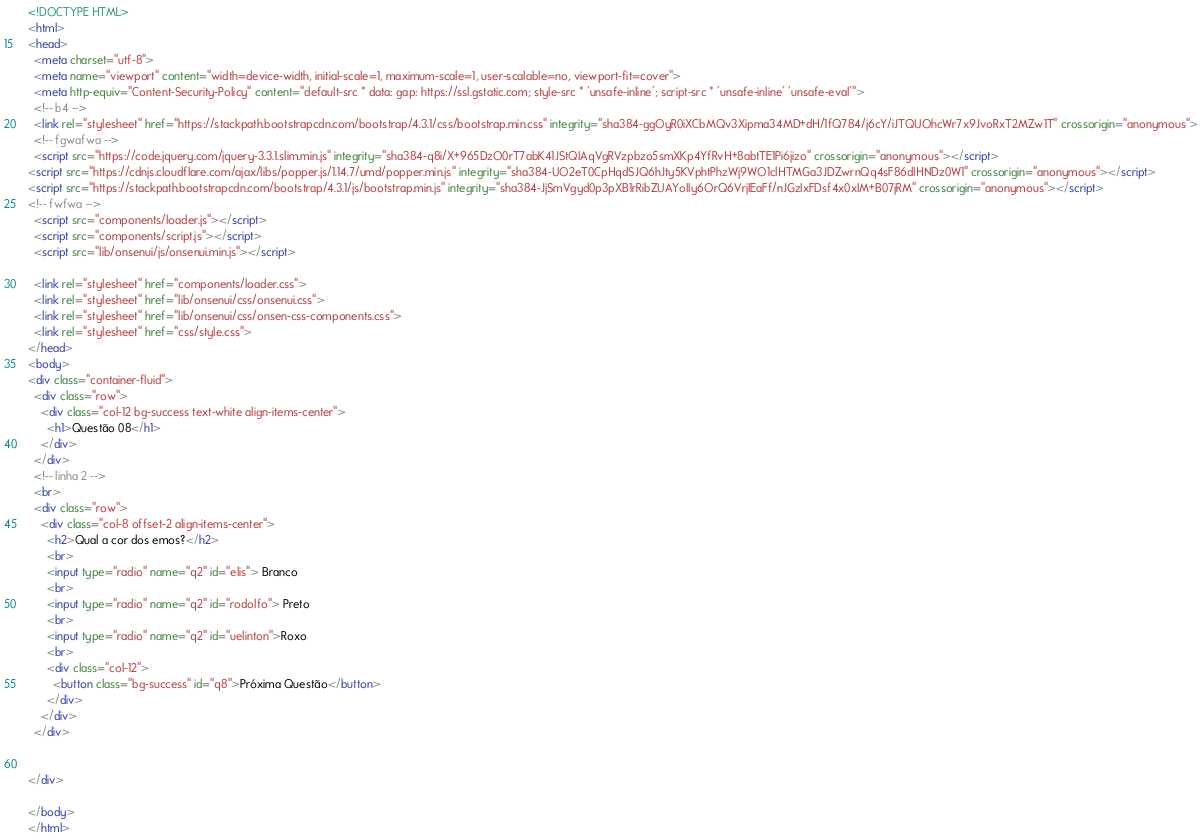Convert code to text. <code><loc_0><loc_0><loc_500><loc_500><_HTML_><!DOCTYPE HTML>
<html>
<head>
  <meta charset="utf-8">
  <meta name="viewport" content="width=device-width, initial-scale=1, maximum-scale=1, user-scalable=no, viewport-fit=cover">
  <meta http-equiv="Content-Security-Policy" content="default-src * data: gap: https://ssl.gstatic.com; style-src * 'unsafe-inline'; script-src * 'unsafe-inline' 'unsafe-eval'">
  <!-- b4 -->
  <link rel="stylesheet" href="https://stackpath.bootstrapcdn.com/bootstrap/4.3.1/css/bootstrap.min.css" integrity="sha384-ggOyR0iXCbMQv3Xipma34MD+dH/1fQ784/j6cY/iJTQUOhcWr7x9JvoRxT2MZw1T" crossorigin="anonymous">
  <!-- fgwafwa -->
  <script src="https://code.jquery.com/jquery-3.3.1.slim.min.js" integrity="sha384-q8i/X+965DzO0rT7abK41JStQIAqVgRVzpbzo5smXKp4YfRvH+8abtTE1Pi6jizo" crossorigin="anonymous"></script>
<script src="https://cdnjs.cloudflare.com/ajax/libs/popper.js/1.14.7/umd/popper.min.js" integrity="sha384-UO2eT0CpHqdSJQ6hJty5KVphtPhzWj9WO1clHTMGa3JDZwrnQq4sF86dIHNDz0W1" crossorigin="anonymous"></script>
<script src="https://stackpath.bootstrapcdn.com/bootstrap/4.3.1/js/bootstrap.min.js" integrity="sha384-JjSmVgyd0p3pXB1rRibZUAYoIIy6OrQ6VrjIEaFf/nJGzIxFDsf4x0xIM+B07jRM" crossorigin="anonymous"></script>
<!-- fwfwa -->
  <script src="components/loader.js"></script>
  <script src="components/script.js"></script>
  <script src="lib/onsenui/js/onsenui.min.js"></script>

  <link rel="stylesheet" href="components/loader.css">
  <link rel="stylesheet" href="lib/onsenui/css/onsenui.css">
  <link rel="stylesheet" href="lib/onsenui/css/onsen-css-components.css">
  <link rel="stylesheet" href="css/style.css">
</head>
<body>
<div class="container-fluid">
  <div class="row">
    <div class="col-12 bg-success text-white align-items-center">
      <h1>Questão 08</h1>
    </div>
  </div>
  <!-- linha 2 -->
  <br>
  <div class="row">
    <div class="col-8 offset-2 align-items-center">
      <h2>Qual a cor dos emos?</h2>
      <br>
      <input type="radio" name="q2" id="elis"> Branco
      <br>
      <input type="radio" name="q2" id="rodolfo"> Preto
      <br>
      <input type="radio" name="q2" id="uelinton">Roxo
      <br>
      <div class="col-12">
        <button class="bg-success" id="q8">Próxima Questão</button>
      </div>
    </div>
  </div>

  
</div>

</body>
</html>
</code> 